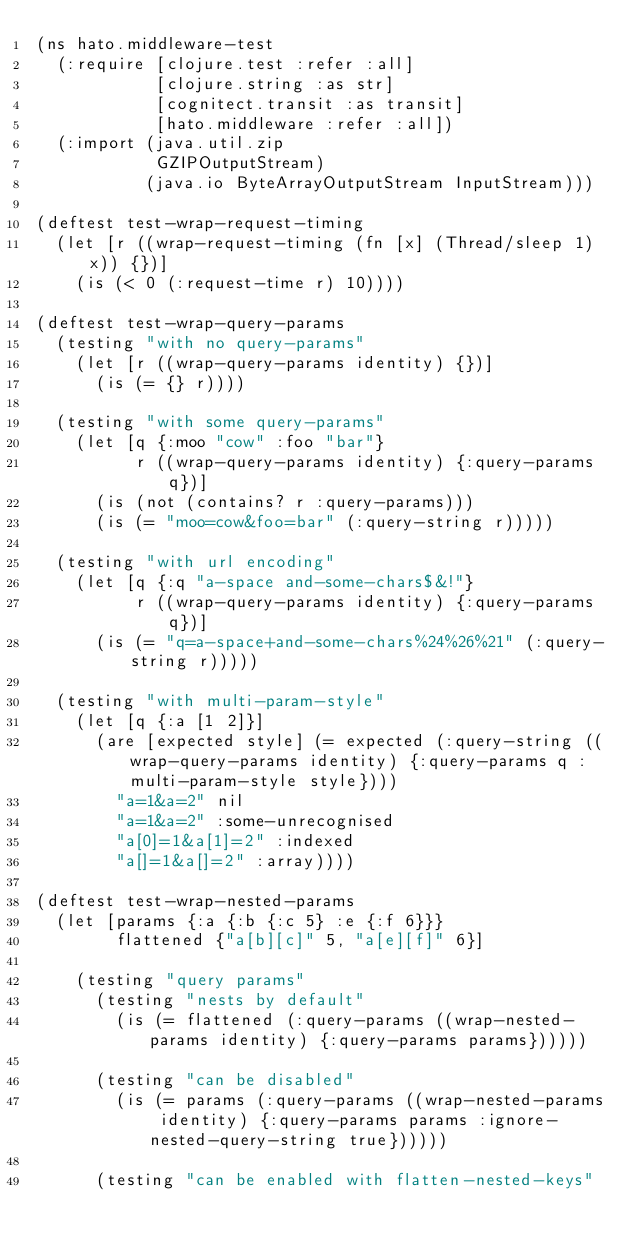<code> <loc_0><loc_0><loc_500><loc_500><_Clojure_>(ns hato.middleware-test
  (:require [clojure.test :refer :all]
            [clojure.string :as str]
            [cognitect.transit :as transit]
            [hato.middleware :refer :all])
  (:import (java.util.zip
            GZIPOutputStream)
           (java.io ByteArrayOutputStream InputStream)))

(deftest test-wrap-request-timing
  (let [r ((wrap-request-timing (fn [x] (Thread/sleep 1) x)) {})]
    (is (< 0 (:request-time r) 10))))

(deftest test-wrap-query-params
  (testing "with no query-params"
    (let [r ((wrap-query-params identity) {})]
      (is (= {} r))))

  (testing "with some query-params"
    (let [q {:moo "cow" :foo "bar"}
          r ((wrap-query-params identity) {:query-params q})]
      (is (not (contains? r :query-params)))
      (is (= "moo=cow&foo=bar" (:query-string r)))))

  (testing "with url encoding"
    (let [q {:q "a-space and-some-chars$&!"}
          r ((wrap-query-params identity) {:query-params q})]
      (is (= "q=a-space+and-some-chars%24%26%21" (:query-string r)))))

  (testing "with multi-param-style"
    (let [q {:a [1 2]}]
      (are [expected style] (= expected (:query-string ((wrap-query-params identity) {:query-params q :multi-param-style style})))
        "a=1&a=2" nil
        "a=1&a=2" :some-unrecognised
        "a[0]=1&a[1]=2" :indexed
        "a[]=1&a[]=2" :array))))

(deftest test-wrap-nested-params
  (let [params {:a {:b {:c 5} :e {:f 6}}}
        flattened {"a[b][c]" 5, "a[e][f]" 6}]

    (testing "query params"
      (testing "nests by default"
        (is (= flattened (:query-params ((wrap-nested-params identity) {:query-params params})))))

      (testing "can be disabled"
        (is (= params (:query-params ((wrap-nested-params identity) {:query-params params :ignore-nested-query-string true})))))

      (testing "can be enabled with flatten-nested-keys"</code> 